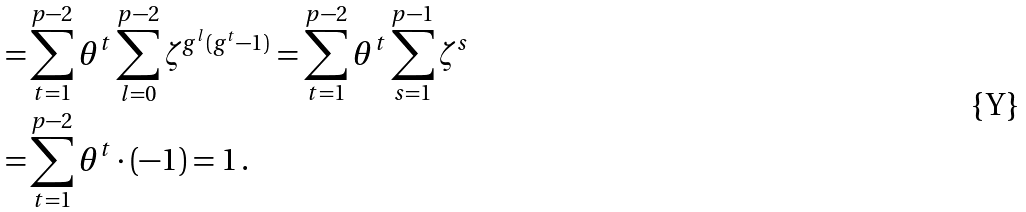<formula> <loc_0><loc_0><loc_500><loc_500>= & \sum _ { t = 1 } ^ { p - 2 } \theta ^ { t } \sum _ { l = 0 } ^ { p - 2 } \zeta ^ { g ^ { l } ( g ^ { t } - 1 ) } = \sum _ { t = 1 } ^ { p - 2 } \theta ^ { t } \sum _ { s = 1 } ^ { p - 1 } \zeta ^ { s } \\ = & \sum _ { t = 1 } ^ { p - 2 } \theta ^ { t } \cdot ( - 1 ) = 1 \, .</formula> 